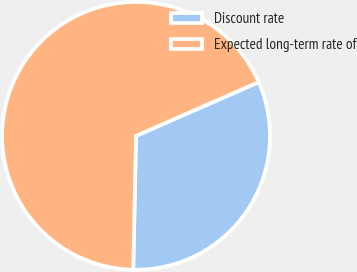<chart> <loc_0><loc_0><loc_500><loc_500><pie_chart><fcel>Discount rate<fcel>Expected long-term rate of<nl><fcel>31.91%<fcel>68.09%<nl></chart> 